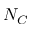Convert formula to latex. <formula><loc_0><loc_0><loc_500><loc_500>N _ { C }</formula> 